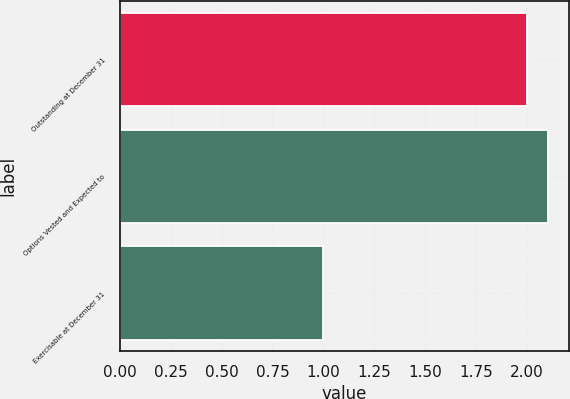<chart> <loc_0><loc_0><loc_500><loc_500><bar_chart><fcel>Outstanding at December 31<fcel>Options Vested and Expected to<fcel>Exercisable at December 31<nl><fcel>2<fcel>2.1<fcel>1<nl></chart> 